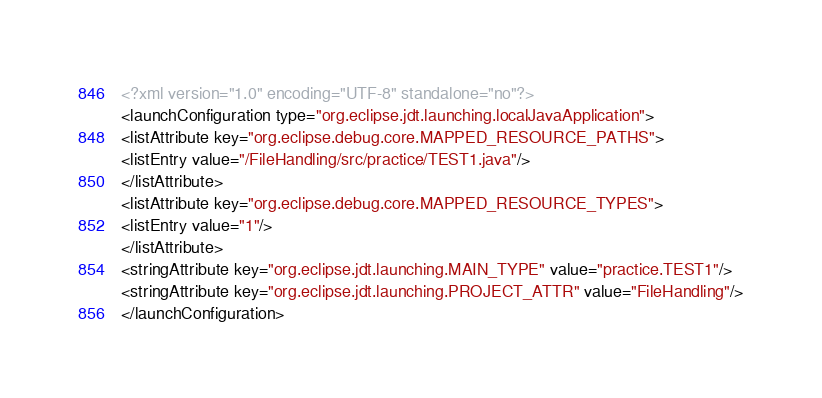<code> <loc_0><loc_0><loc_500><loc_500><_XML_><?xml version="1.0" encoding="UTF-8" standalone="no"?>
<launchConfiguration type="org.eclipse.jdt.launching.localJavaApplication">
<listAttribute key="org.eclipse.debug.core.MAPPED_RESOURCE_PATHS">
<listEntry value="/FileHandling/src/practice/TEST1.java"/>
</listAttribute>
<listAttribute key="org.eclipse.debug.core.MAPPED_RESOURCE_TYPES">
<listEntry value="1"/>
</listAttribute>
<stringAttribute key="org.eclipse.jdt.launching.MAIN_TYPE" value="practice.TEST1"/>
<stringAttribute key="org.eclipse.jdt.launching.PROJECT_ATTR" value="FileHandling"/>
</launchConfiguration>
</code> 